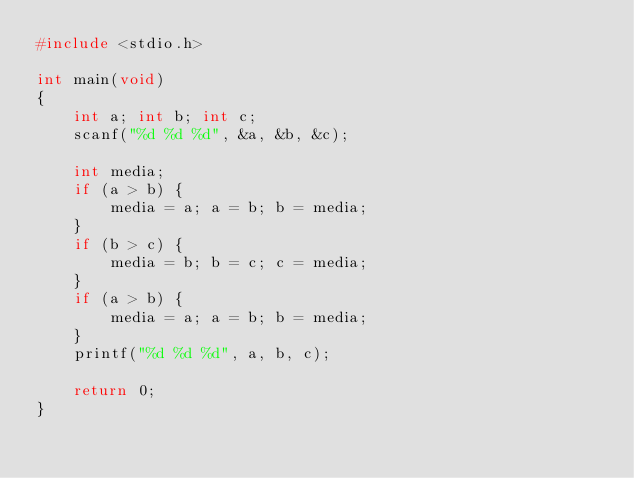<code> <loc_0><loc_0><loc_500><loc_500><_C_>#include <stdio.h>

int main(void)
{
	int a; int b; int c;
	scanf("%d %d %d", &a, &b, &c);

	int media;
	if (a > b) {
		media = a; a = b; b = media;
	}
	if (b > c) {
		media = b; b = c; c = media;
	}
	if (a > b) {
		media = a; a = b; b = media;
	}
	printf("%d %d %d", a, b, c);

	return 0;
}</code> 